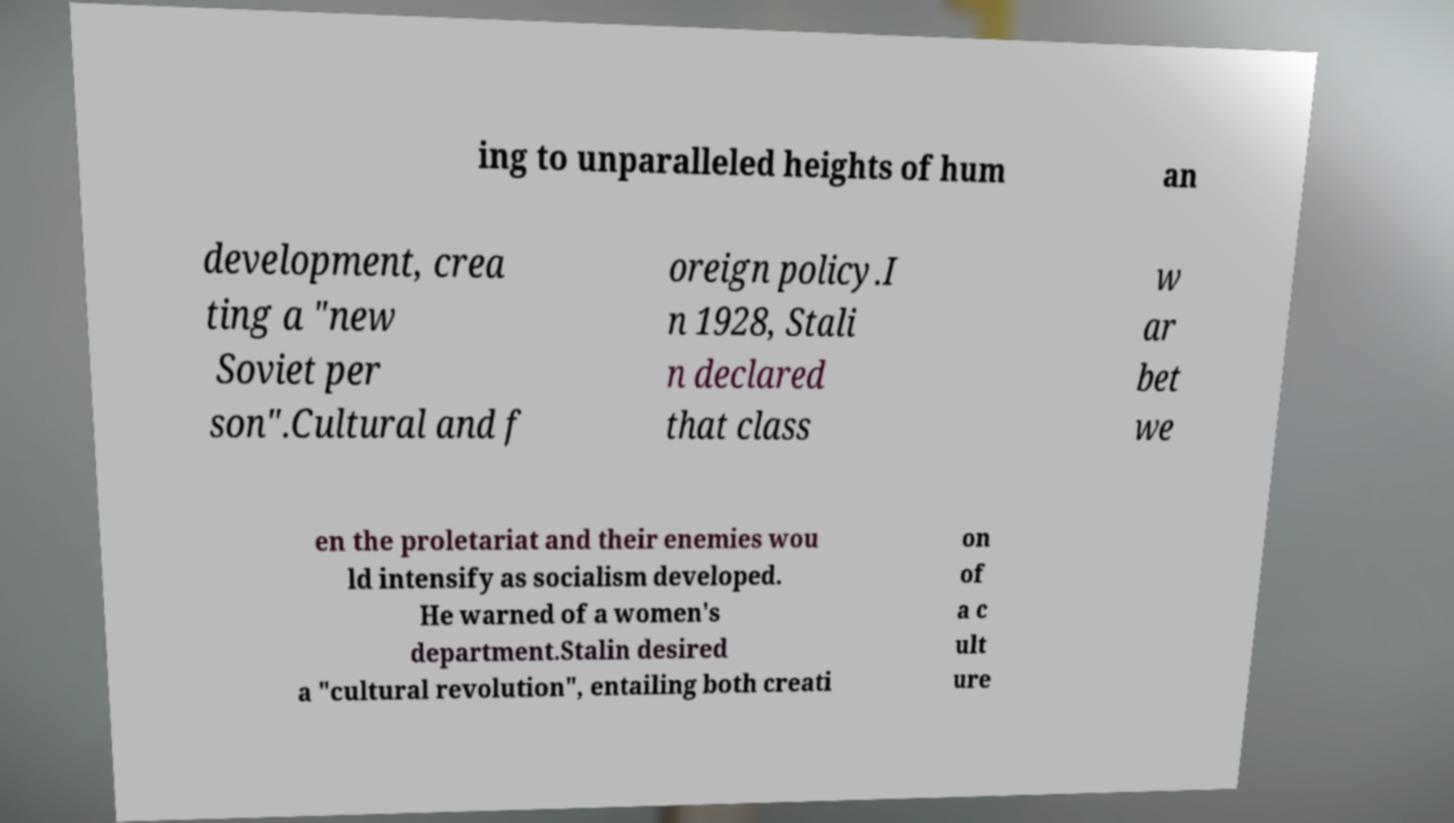For documentation purposes, I need the text within this image transcribed. Could you provide that? ing to unparalleled heights of hum an development, crea ting a "new Soviet per son".Cultural and f oreign policy.I n 1928, Stali n declared that class w ar bet we en the proletariat and their enemies wou ld intensify as socialism developed. He warned of a women's department.Stalin desired a "cultural revolution", entailing both creati on of a c ult ure 